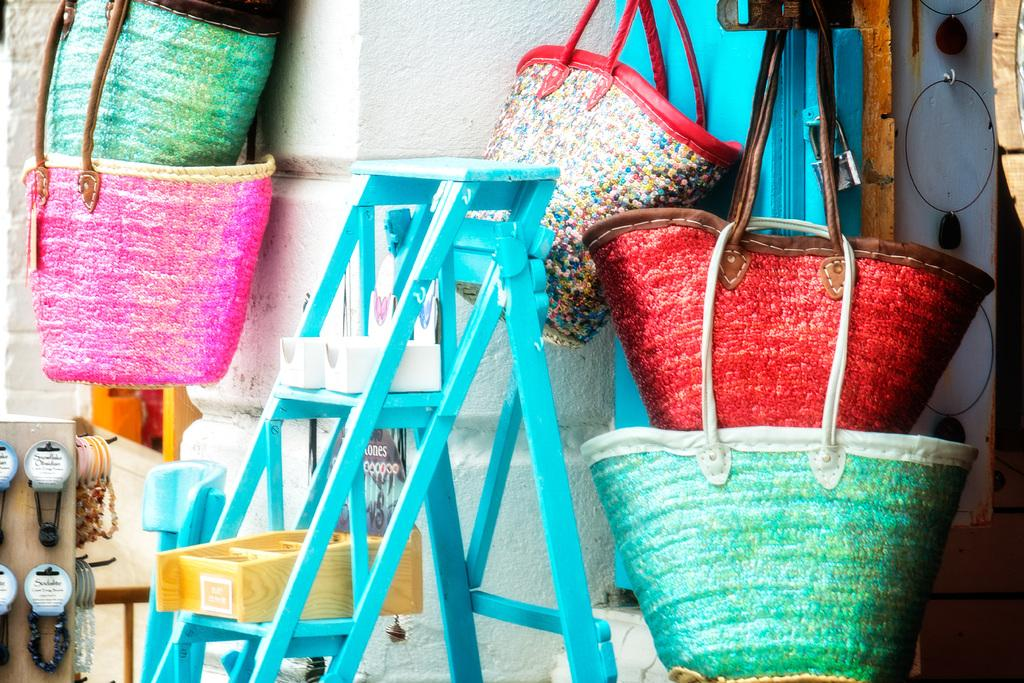What objects can be seen on the left side of the image? There are two colorful bags on the left side of the image. What is located on the right side of the image? There is a wall on the right side of the image. What is in the middle of the image? There is a ladder in the middle of the image. What type of drawer is being discussed in the image? There is no drawer present in the image, so it cannot be discussed. How does the light affect the appearance of the objects in the image? There is no mention of light in the image, so its effect on the objects cannot be determined. 